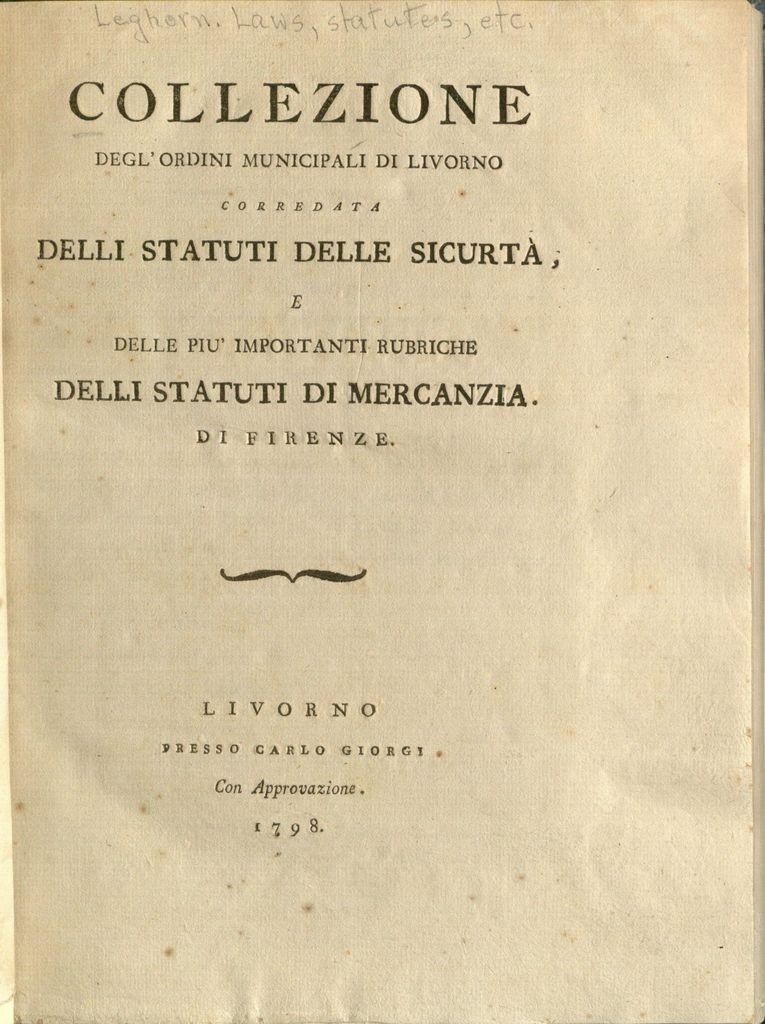<image>
Present a compact description of the photo's key features. An old open book with the title page saying Collezione. 